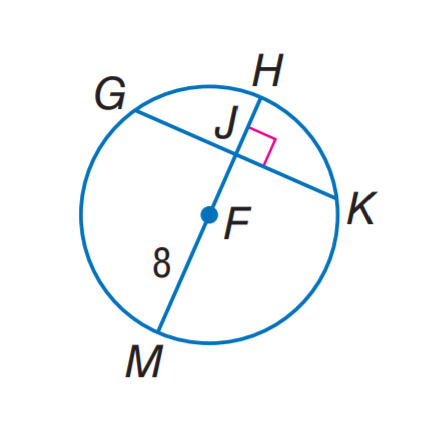Question: In \odot F, G K = 14 and m \widehat G H K = 142. Find J K.
Choices:
A. 7
B. 8
C. 14
D. 16
Answer with the letter. Answer: A Question: In \odot F, G K = 14 and m \widehat G H K = 142. Find m \widehat K M.
Choices:
A. 99
B. 109
C. 113
D. 142
Answer with the letter. Answer: B Question: In \odot F, G K = 14 and m \widehat G H K = 142. Find m \widehat G H.
Choices:
A. 38
B. 71
C. 76
D. 142
Answer with the letter. Answer: B 